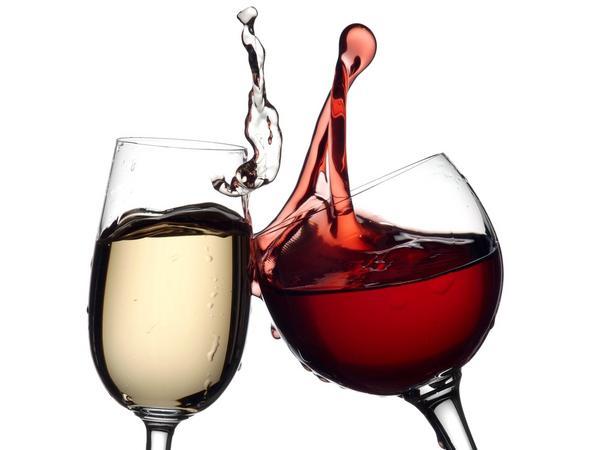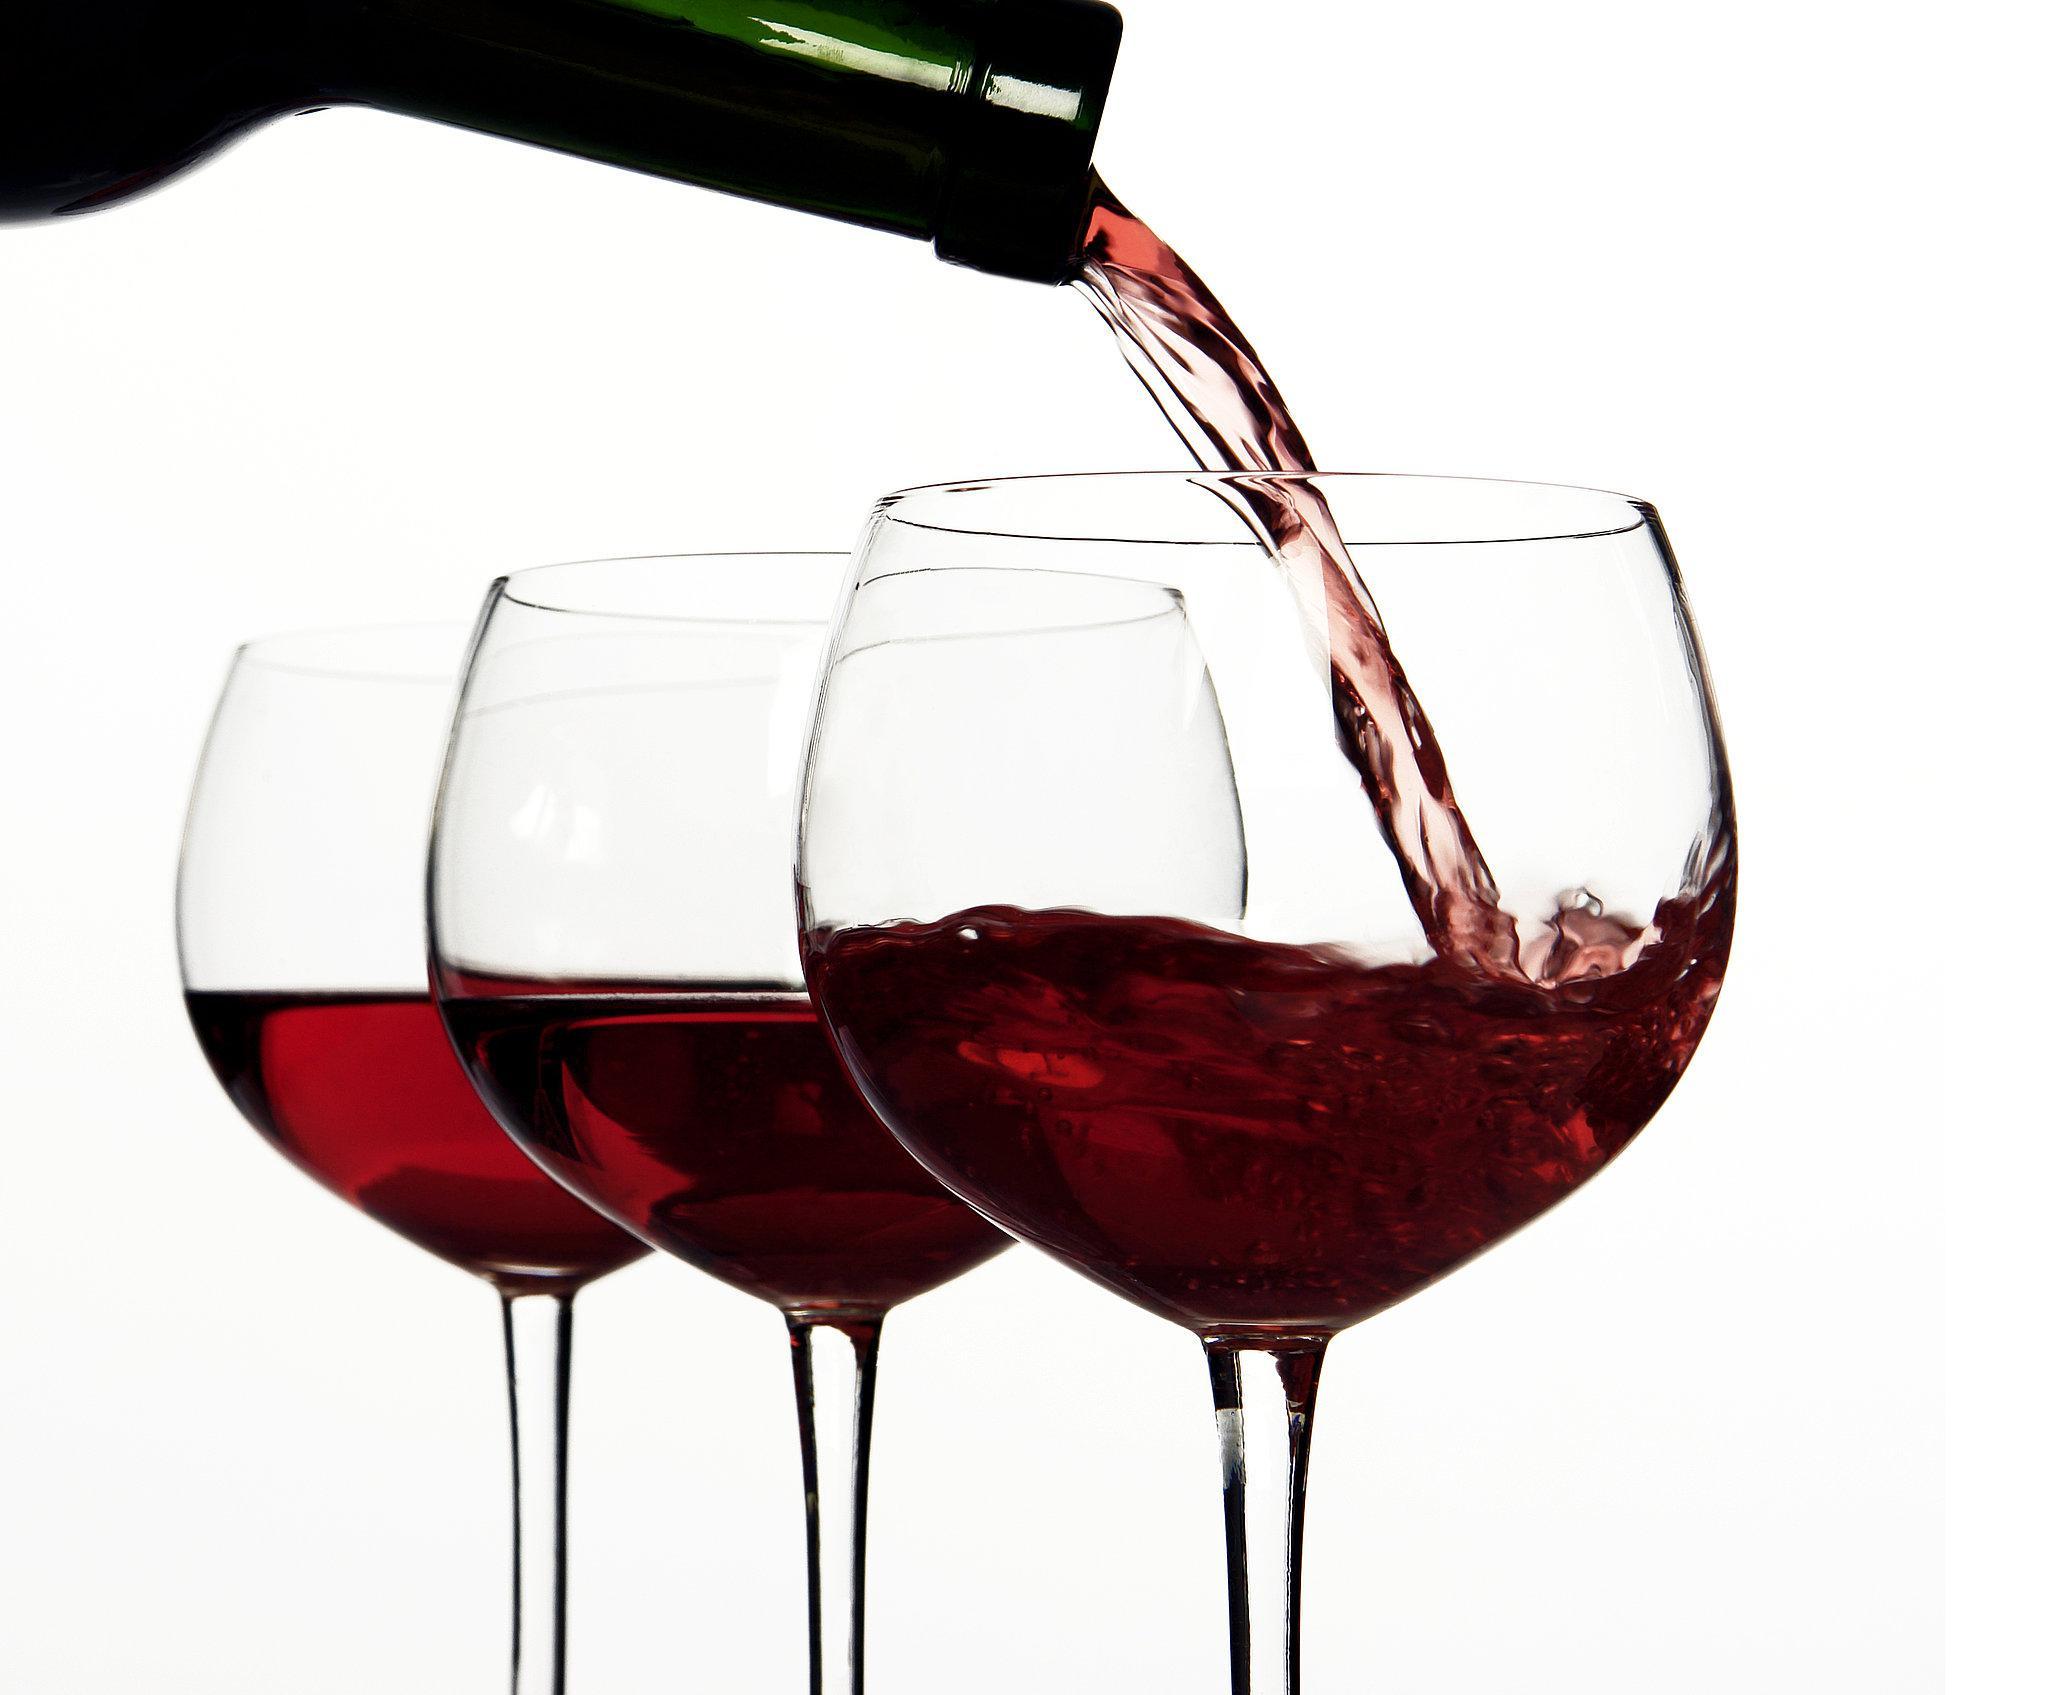The first image is the image on the left, the second image is the image on the right. Examine the images to the left and right. Is the description "At least one image has more than one wine glass in it." accurate? Answer yes or no. Yes. 